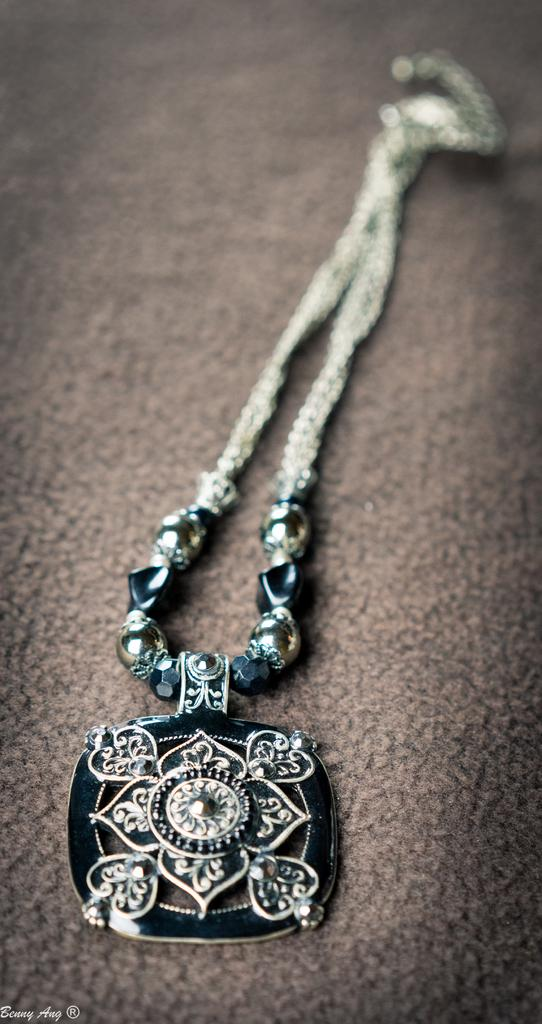What can be seen in the picture? There is an ornament in the picture. What is located at the bottom of the picture? There is a mat at the bottom of the picture. Where is the text in the picture? The text is at the bottom left of the picture. What type of whistle can be heard in the image? There is no whistle present in the image, and therefore no sound can be heard. How many apples are on the ornament in the image? There is no mention of apples in the image, and the ornament's design is not described. 